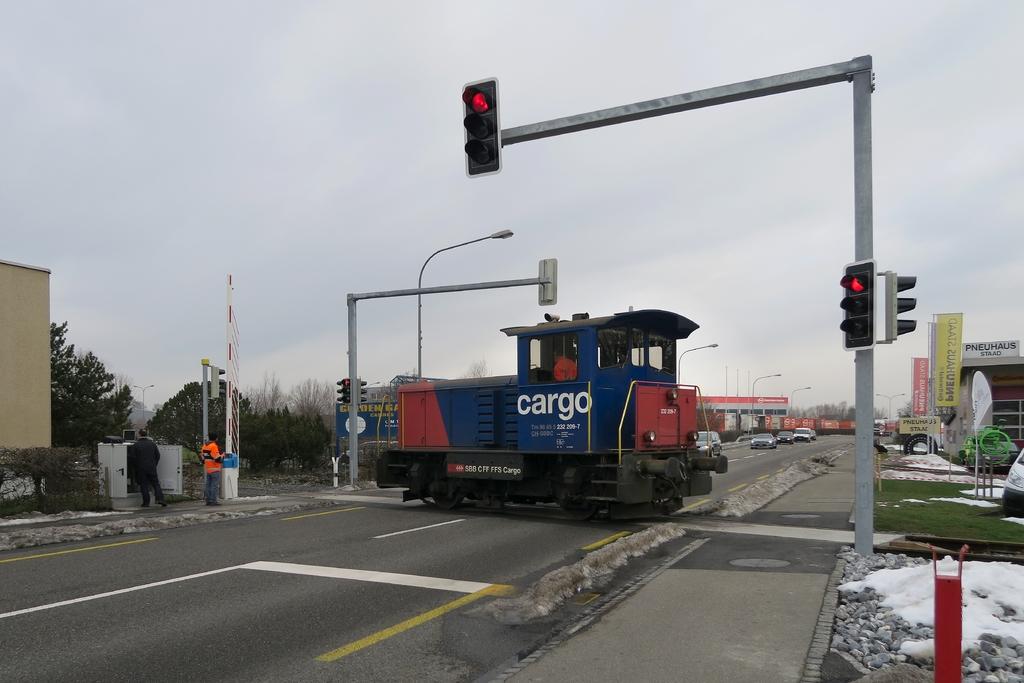What is that vehicle called?
Your response must be concise. Cargo. Road making vechicle?
Offer a very short reply. No. 